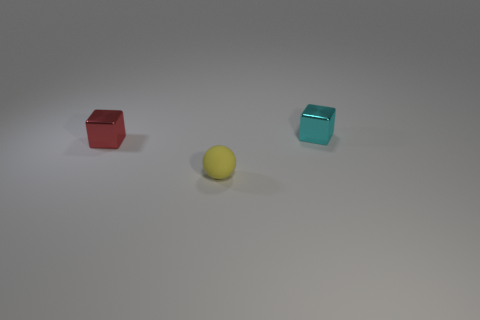There is a block that is behind the small shiny block that is to the left of the tiny cyan shiny block; what is its material?
Keep it short and to the point. Metal. There is a small cyan thing that is the same shape as the tiny red object; what material is it?
Give a very brief answer. Metal. There is a shiny thing on the right side of the red cube; does it have the same size as the tiny red metal block?
Make the answer very short. Yes. What number of rubber things are big purple objects or tiny cyan objects?
Provide a succinct answer. 0. What is the thing that is both in front of the small cyan metallic block and behind the yellow matte sphere made of?
Provide a short and direct response. Metal. Are the tiny yellow object and the small cyan object made of the same material?
Keep it short and to the point. No. There is a thing that is both behind the yellow rubber thing and to the left of the small cyan thing; what size is it?
Your answer should be compact. Small. There is a cyan thing; what shape is it?
Make the answer very short. Cube. How many objects are small red objects or tiny things that are in front of the tiny red thing?
Provide a succinct answer. 2. Does the small shiny block that is behind the red metal object have the same color as the tiny matte thing?
Keep it short and to the point. No. 